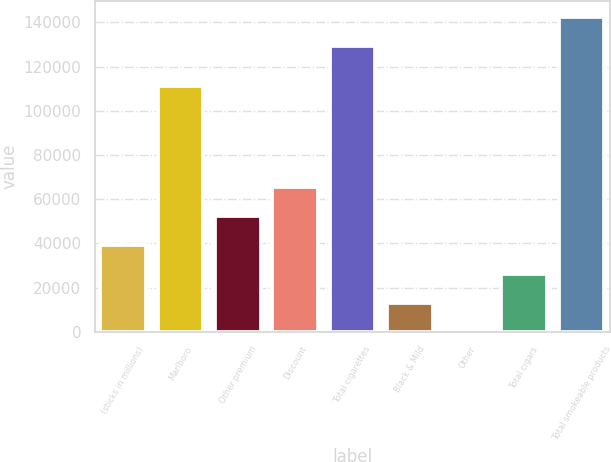Convert chart to OTSL. <chart><loc_0><loc_0><loc_500><loc_500><bar_chart><fcel>(sticks in millions)<fcel>Marlboro<fcel>Other premium<fcel>Discount<fcel>Total cigarettes<fcel>Black & Mild<fcel>Other<fcel>Total cigars<fcel>Total smokeable products<nl><fcel>39167.7<fcel>111421<fcel>52216.6<fcel>65265.5<fcel>129312<fcel>13069.9<fcel>21<fcel>26118.8<fcel>142361<nl></chart> 